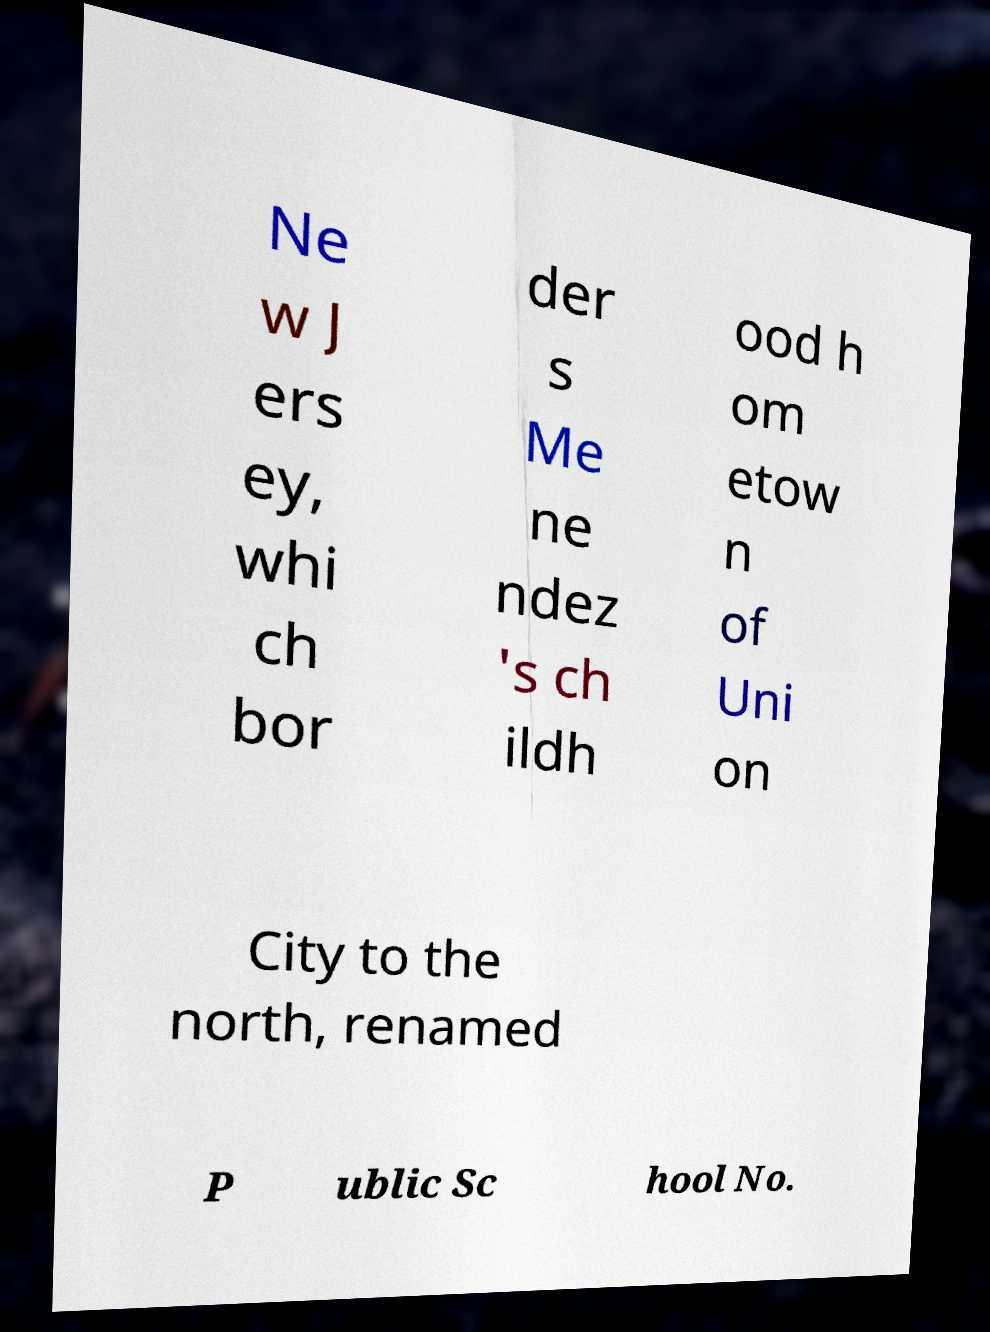I need the written content from this picture converted into text. Can you do that? Ne w J ers ey, whi ch bor der s Me ne ndez 's ch ildh ood h om etow n of Uni on City to the north, renamed P ublic Sc hool No. 